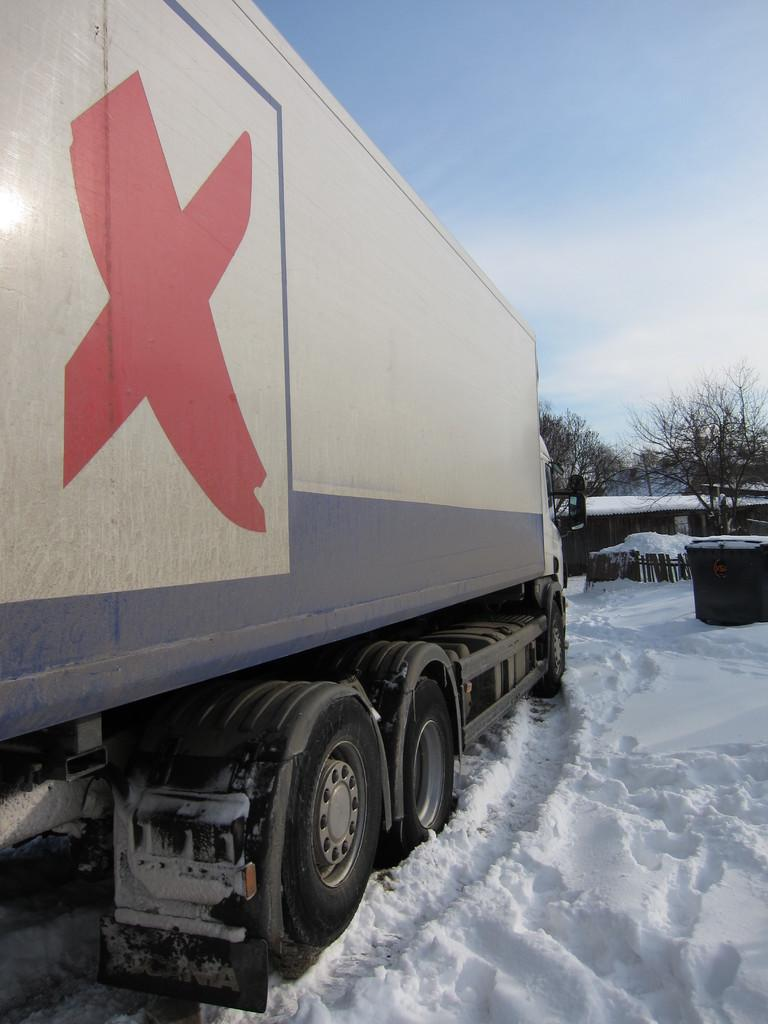What is the main subject of the image? There is a vehicle in the snow. What can be seen in front of the vehicle? There are trees and a house in front of the vehicle. What is visible in the background of the image? The sky is visible in the image. What is the object in front of the vehicle? There is an object in front of the vehicle, but it is not specified in the facts. What type of ornament is hanging from the trees in the image? There is no mention of any ornaments hanging from the trees in the image. 